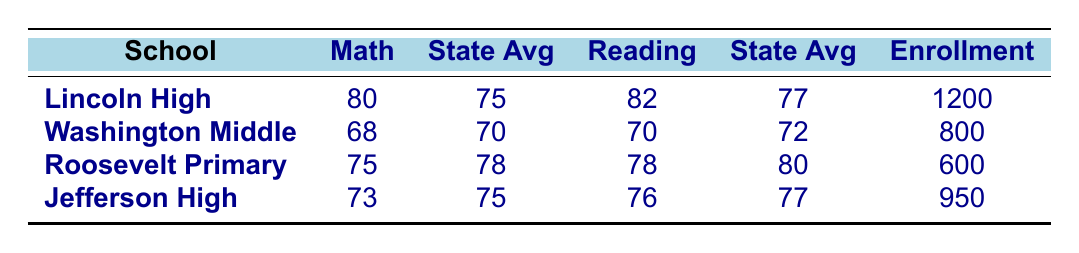What is the math score of Lincoln High School? The table shows that Lincoln High School has a math score of 80.
Answer: 80 How does the reading score of Washington Middle School compare to the state average? Washington Middle School has a reading score of 70, while the state average is 72, indicating that it is below the state average.
Answer: Below average Which school has the highest graduation rate? Lincoln High School has a graduation rate of 90, which is greater than Jefferson High School's 88 and higher than the other schools listed that do not have a recorded graduation rate.
Answer: Lincoln High School What is the difference between the school math score and the state average for Roosevelt Primary School? Roosevelt Primary School has a math score of 75 and a state average of 78. The difference is 78 - 75 = 3.
Answer: 3 Is it true that all schools have a math score above the state average? No, Washington Middle School has a math score of 68, which is below the state average of 70.
Answer: No What is the average reading score for the local schools listed? The reading scores are 82, 70, 78, and 76. The total is 82 + 70 + 78 + 76 = 306. There are 4 schools, so the average is 306 / 4 = 76.5.
Answer: 76.5 How many students are enrolled at Jefferson High School? According to the table, Jefferson High School has an enrollment of 950 students.
Answer: 950 Which school has an enrollment greater than 800 students and what is its math score? Lincoln High School and Jefferson High School both have enrollments greater than 800 students, with math scores of 80 and 73 respectively.
Answer: Lincoln: 80, Jefferson: 73 What is the total enrollment of all schools listed? The enrollments are 1200, 800, 600, and 950. Adding them gives 1200 + 800 + 600 + 950 = 3550.
Answer: 3550 